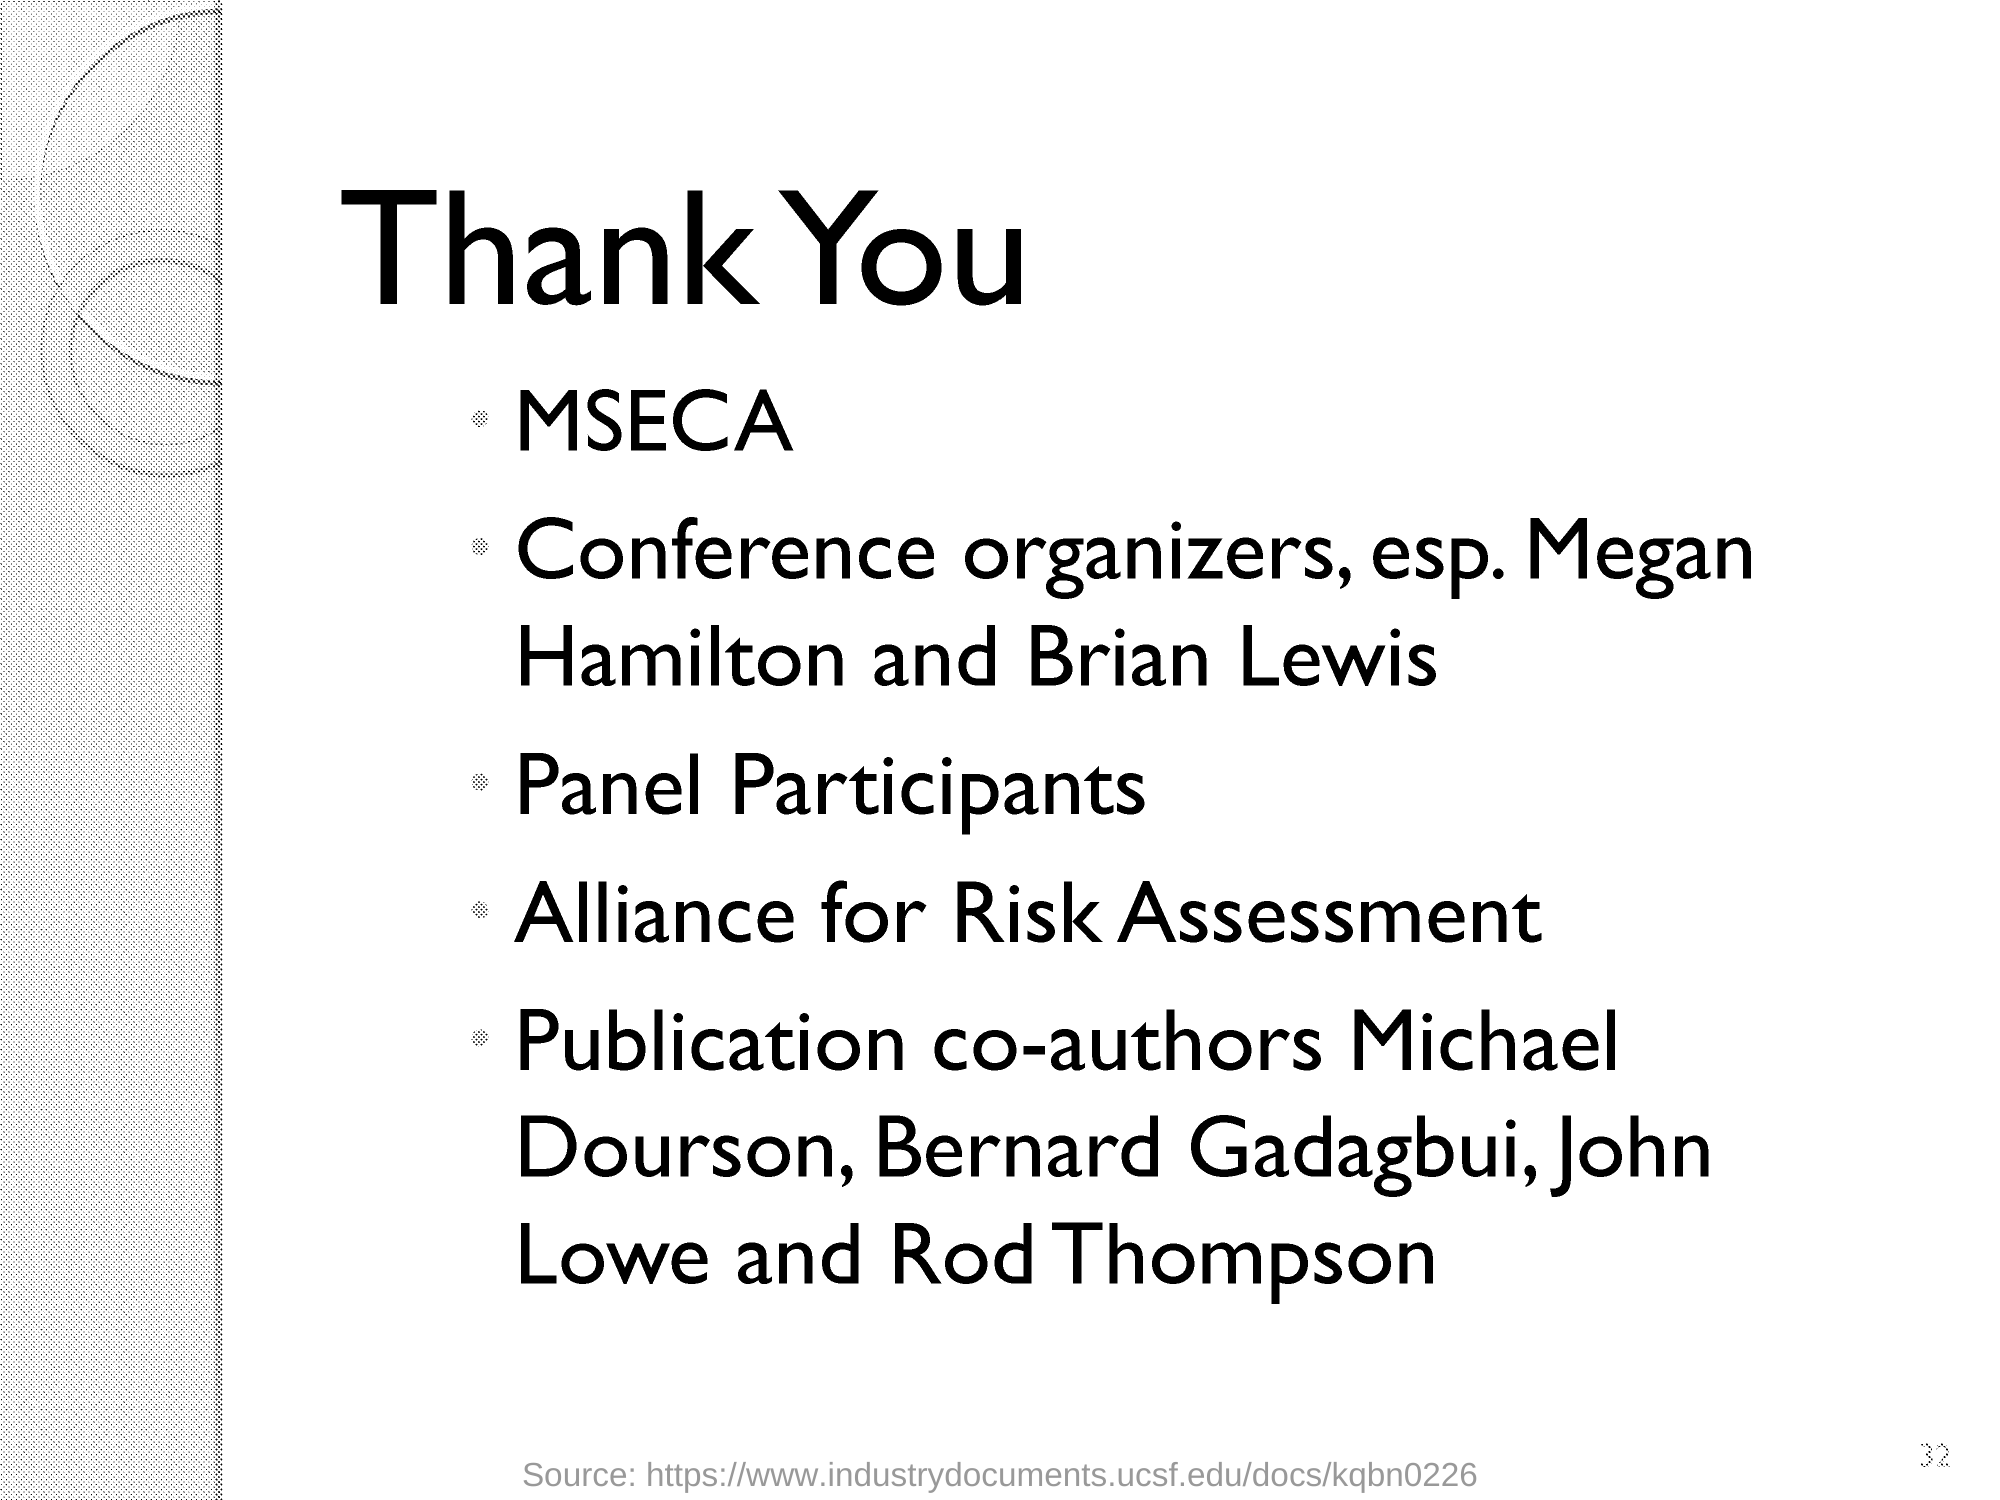What is the heading of the document?
Your answer should be very brief. Thank You. Who are the Publication co-authors?
Your response must be concise. Michael Dourson, Bernard Gadagbui, John Lowe and Rod Thompson. 